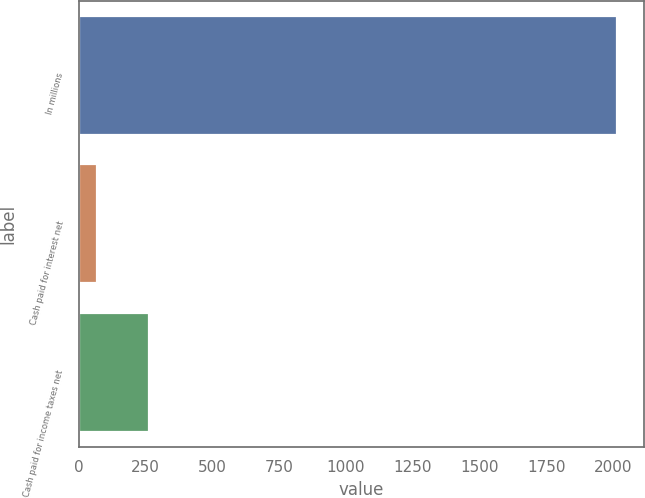Convert chart. <chart><loc_0><loc_0><loc_500><loc_500><bar_chart><fcel>In millions<fcel>Cash paid for interest net<fcel>Cash paid for income taxes net<nl><fcel>2014<fcel>67.5<fcel>262.15<nl></chart> 